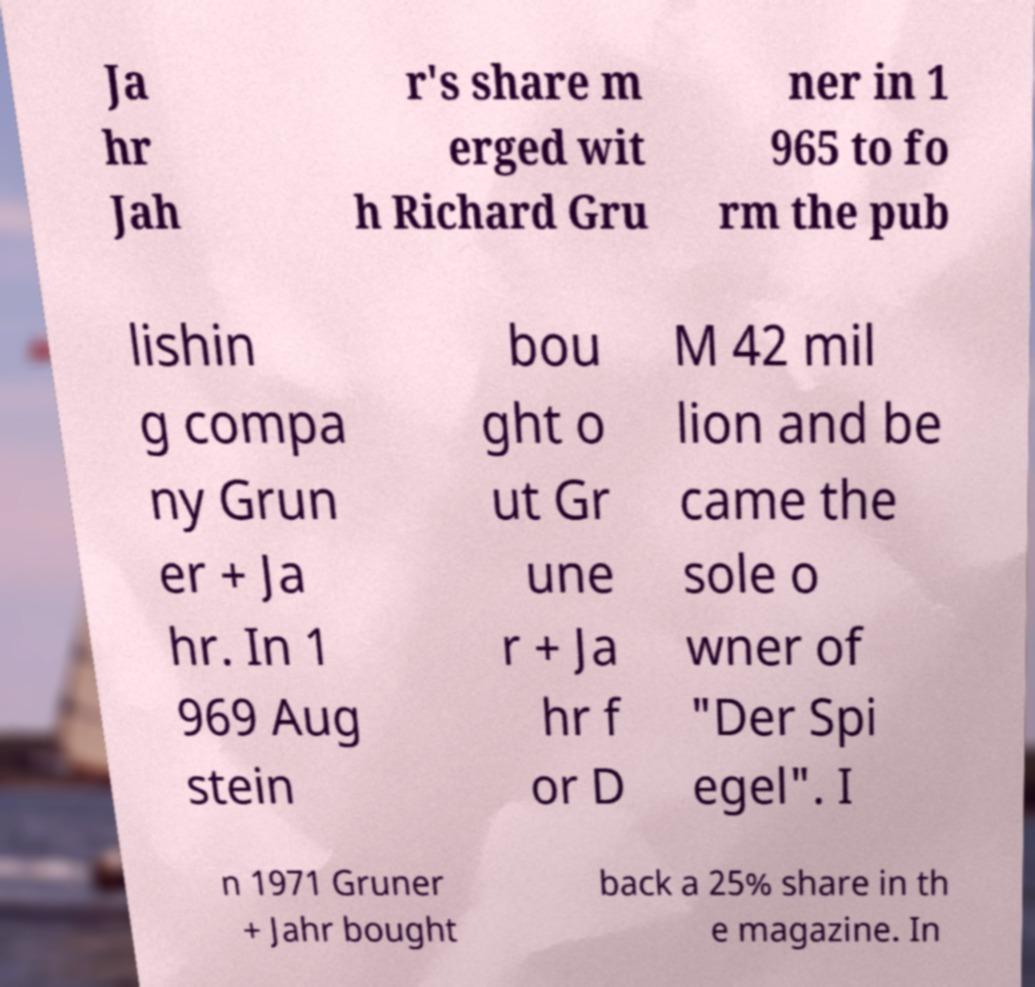Could you extract and type out the text from this image? Ja hr Jah r's share m erged wit h Richard Gru ner in 1 965 to fo rm the pub lishin g compa ny Grun er + Ja hr. In 1 969 Aug stein bou ght o ut Gr une r + Ja hr f or D M 42 mil lion and be came the sole o wner of "Der Spi egel". I n 1971 Gruner + Jahr bought back a 25% share in th e magazine. In 